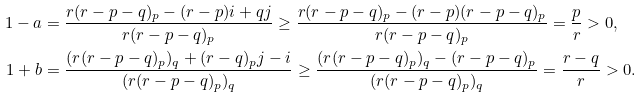Convert formula to latex. <formula><loc_0><loc_0><loc_500><loc_500>1 - a & = \frac { r ( r - p - q ) _ { p } - ( r - p ) i + q j } { r ( r - p - q ) _ { p } } \geq \frac { r ( r - p - q ) _ { p } - ( r - p ) ( r - p - q ) _ { p } } { r ( r - p - q ) _ { p } } = \frac { p } { r } > 0 , \\ 1 + b & = \frac { ( r ( r - p - q ) _ { p } ) _ { q } + ( r - q ) _ { p } j - i } { ( r ( r - p - q ) _ { p } ) _ { q } } \geq \frac { ( r ( r - p - q ) _ { p } ) _ { q } - ( r - p - q ) _ { p } } { ( r ( r - p - q ) _ { p } ) _ { q } } = \frac { r - q } { r } > 0 .</formula> 